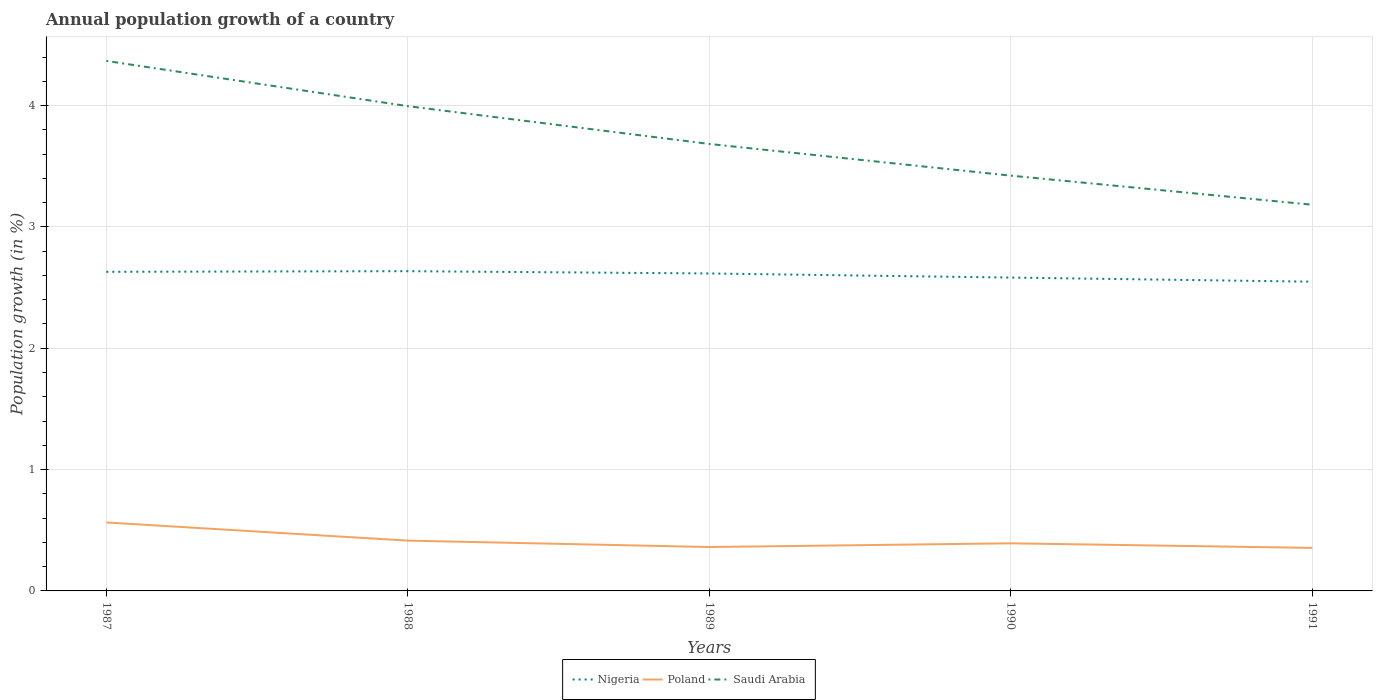How many different coloured lines are there?
Offer a very short reply. 3. Across all years, what is the maximum annual population growth in Saudi Arabia?
Your answer should be very brief. 3.18. In which year was the annual population growth in Saudi Arabia maximum?
Ensure brevity in your answer.  1991. What is the total annual population growth in Nigeria in the graph?
Give a very brief answer. 0.01. What is the difference between the highest and the second highest annual population growth in Saudi Arabia?
Your answer should be very brief. 1.19. How many years are there in the graph?
Your answer should be compact. 5. Are the values on the major ticks of Y-axis written in scientific E-notation?
Ensure brevity in your answer.  No. Does the graph contain grids?
Give a very brief answer. Yes. What is the title of the graph?
Make the answer very short. Annual population growth of a country. What is the label or title of the Y-axis?
Provide a succinct answer. Population growth (in %). What is the Population growth (in %) of Nigeria in 1987?
Keep it short and to the point. 2.63. What is the Population growth (in %) in Poland in 1987?
Your answer should be compact. 0.56. What is the Population growth (in %) of Saudi Arabia in 1987?
Provide a short and direct response. 4.37. What is the Population growth (in %) of Nigeria in 1988?
Your answer should be very brief. 2.64. What is the Population growth (in %) of Poland in 1988?
Provide a short and direct response. 0.41. What is the Population growth (in %) of Saudi Arabia in 1988?
Give a very brief answer. 4. What is the Population growth (in %) in Nigeria in 1989?
Provide a short and direct response. 2.62. What is the Population growth (in %) in Poland in 1989?
Provide a succinct answer. 0.36. What is the Population growth (in %) of Saudi Arabia in 1989?
Your answer should be compact. 3.68. What is the Population growth (in %) in Nigeria in 1990?
Your answer should be compact. 2.58. What is the Population growth (in %) of Poland in 1990?
Offer a very short reply. 0.39. What is the Population growth (in %) of Saudi Arabia in 1990?
Make the answer very short. 3.42. What is the Population growth (in %) of Nigeria in 1991?
Your answer should be very brief. 2.55. What is the Population growth (in %) of Poland in 1991?
Your answer should be very brief. 0.35. What is the Population growth (in %) in Saudi Arabia in 1991?
Offer a very short reply. 3.18. Across all years, what is the maximum Population growth (in %) in Nigeria?
Make the answer very short. 2.64. Across all years, what is the maximum Population growth (in %) of Poland?
Provide a succinct answer. 0.56. Across all years, what is the maximum Population growth (in %) in Saudi Arabia?
Your response must be concise. 4.37. Across all years, what is the minimum Population growth (in %) of Nigeria?
Ensure brevity in your answer.  2.55. Across all years, what is the minimum Population growth (in %) in Poland?
Your response must be concise. 0.35. Across all years, what is the minimum Population growth (in %) in Saudi Arabia?
Provide a succinct answer. 3.18. What is the total Population growth (in %) of Nigeria in the graph?
Provide a short and direct response. 13.01. What is the total Population growth (in %) in Poland in the graph?
Ensure brevity in your answer.  2.09. What is the total Population growth (in %) of Saudi Arabia in the graph?
Offer a very short reply. 18.65. What is the difference between the Population growth (in %) in Nigeria in 1987 and that in 1988?
Your answer should be compact. -0.01. What is the difference between the Population growth (in %) of Poland in 1987 and that in 1988?
Your response must be concise. 0.15. What is the difference between the Population growth (in %) in Saudi Arabia in 1987 and that in 1988?
Provide a succinct answer. 0.37. What is the difference between the Population growth (in %) in Nigeria in 1987 and that in 1989?
Offer a very short reply. 0.01. What is the difference between the Population growth (in %) of Poland in 1987 and that in 1989?
Give a very brief answer. 0.2. What is the difference between the Population growth (in %) of Saudi Arabia in 1987 and that in 1989?
Offer a very short reply. 0.68. What is the difference between the Population growth (in %) of Nigeria in 1987 and that in 1990?
Make the answer very short. 0.05. What is the difference between the Population growth (in %) in Poland in 1987 and that in 1990?
Make the answer very short. 0.17. What is the difference between the Population growth (in %) of Saudi Arabia in 1987 and that in 1990?
Offer a terse response. 0.95. What is the difference between the Population growth (in %) of Nigeria in 1987 and that in 1991?
Your response must be concise. 0.08. What is the difference between the Population growth (in %) in Poland in 1987 and that in 1991?
Offer a very short reply. 0.21. What is the difference between the Population growth (in %) in Saudi Arabia in 1987 and that in 1991?
Ensure brevity in your answer.  1.19. What is the difference between the Population growth (in %) of Nigeria in 1988 and that in 1989?
Give a very brief answer. 0.02. What is the difference between the Population growth (in %) of Poland in 1988 and that in 1989?
Provide a short and direct response. 0.05. What is the difference between the Population growth (in %) of Saudi Arabia in 1988 and that in 1989?
Offer a terse response. 0.31. What is the difference between the Population growth (in %) of Nigeria in 1988 and that in 1990?
Give a very brief answer. 0.05. What is the difference between the Population growth (in %) of Poland in 1988 and that in 1990?
Provide a succinct answer. 0.02. What is the difference between the Population growth (in %) in Saudi Arabia in 1988 and that in 1990?
Ensure brevity in your answer.  0.57. What is the difference between the Population growth (in %) of Nigeria in 1988 and that in 1991?
Make the answer very short. 0.09. What is the difference between the Population growth (in %) in Poland in 1988 and that in 1991?
Ensure brevity in your answer.  0.06. What is the difference between the Population growth (in %) in Saudi Arabia in 1988 and that in 1991?
Your answer should be compact. 0.81. What is the difference between the Population growth (in %) in Nigeria in 1989 and that in 1990?
Offer a very short reply. 0.03. What is the difference between the Population growth (in %) of Poland in 1989 and that in 1990?
Offer a terse response. -0.03. What is the difference between the Population growth (in %) in Saudi Arabia in 1989 and that in 1990?
Your answer should be compact. 0.26. What is the difference between the Population growth (in %) of Nigeria in 1989 and that in 1991?
Your answer should be very brief. 0.07. What is the difference between the Population growth (in %) of Poland in 1989 and that in 1991?
Give a very brief answer. 0.01. What is the difference between the Population growth (in %) of Saudi Arabia in 1989 and that in 1991?
Offer a very short reply. 0.5. What is the difference between the Population growth (in %) in Nigeria in 1990 and that in 1991?
Make the answer very short. 0.03. What is the difference between the Population growth (in %) of Poland in 1990 and that in 1991?
Your response must be concise. 0.04. What is the difference between the Population growth (in %) in Saudi Arabia in 1990 and that in 1991?
Offer a very short reply. 0.24. What is the difference between the Population growth (in %) in Nigeria in 1987 and the Population growth (in %) in Poland in 1988?
Give a very brief answer. 2.22. What is the difference between the Population growth (in %) in Nigeria in 1987 and the Population growth (in %) in Saudi Arabia in 1988?
Provide a succinct answer. -1.37. What is the difference between the Population growth (in %) in Poland in 1987 and the Population growth (in %) in Saudi Arabia in 1988?
Your response must be concise. -3.43. What is the difference between the Population growth (in %) of Nigeria in 1987 and the Population growth (in %) of Poland in 1989?
Provide a short and direct response. 2.27. What is the difference between the Population growth (in %) of Nigeria in 1987 and the Population growth (in %) of Saudi Arabia in 1989?
Ensure brevity in your answer.  -1.05. What is the difference between the Population growth (in %) of Poland in 1987 and the Population growth (in %) of Saudi Arabia in 1989?
Keep it short and to the point. -3.12. What is the difference between the Population growth (in %) of Nigeria in 1987 and the Population growth (in %) of Poland in 1990?
Your response must be concise. 2.24. What is the difference between the Population growth (in %) of Nigeria in 1987 and the Population growth (in %) of Saudi Arabia in 1990?
Give a very brief answer. -0.79. What is the difference between the Population growth (in %) in Poland in 1987 and the Population growth (in %) in Saudi Arabia in 1990?
Your answer should be compact. -2.86. What is the difference between the Population growth (in %) of Nigeria in 1987 and the Population growth (in %) of Poland in 1991?
Your response must be concise. 2.28. What is the difference between the Population growth (in %) in Nigeria in 1987 and the Population growth (in %) in Saudi Arabia in 1991?
Ensure brevity in your answer.  -0.55. What is the difference between the Population growth (in %) in Poland in 1987 and the Population growth (in %) in Saudi Arabia in 1991?
Give a very brief answer. -2.62. What is the difference between the Population growth (in %) in Nigeria in 1988 and the Population growth (in %) in Poland in 1989?
Ensure brevity in your answer.  2.27. What is the difference between the Population growth (in %) of Nigeria in 1988 and the Population growth (in %) of Saudi Arabia in 1989?
Provide a succinct answer. -1.05. What is the difference between the Population growth (in %) of Poland in 1988 and the Population growth (in %) of Saudi Arabia in 1989?
Keep it short and to the point. -3.27. What is the difference between the Population growth (in %) in Nigeria in 1988 and the Population growth (in %) in Poland in 1990?
Your answer should be very brief. 2.24. What is the difference between the Population growth (in %) of Nigeria in 1988 and the Population growth (in %) of Saudi Arabia in 1990?
Your response must be concise. -0.79. What is the difference between the Population growth (in %) of Poland in 1988 and the Population growth (in %) of Saudi Arabia in 1990?
Offer a terse response. -3.01. What is the difference between the Population growth (in %) in Nigeria in 1988 and the Population growth (in %) in Poland in 1991?
Provide a succinct answer. 2.28. What is the difference between the Population growth (in %) of Nigeria in 1988 and the Population growth (in %) of Saudi Arabia in 1991?
Provide a short and direct response. -0.55. What is the difference between the Population growth (in %) in Poland in 1988 and the Population growth (in %) in Saudi Arabia in 1991?
Ensure brevity in your answer.  -2.77. What is the difference between the Population growth (in %) of Nigeria in 1989 and the Population growth (in %) of Poland in 1990?
Provide a succinct answer. 2.22. What is the difference between the Population growth (in %) of Nigeria in 1989 and the Population growth (in %) of Saudi Arabia in 1990?
Offer a very short reply. -0.81. What is the difference between the Population growth (in %) in Poland in 1989 and the Population growth (in %) in Saudi Arabia in 1990?
Your response must be concise. -3.06. What is the difference between the Population growth (in %) of Nigeria in 1989 and the Population growth (in %) of Poland in 1991?
Ensure brevity in your answer.  2.26. What is the difference between the Population growth (in %) of Nigeria in 1989 and the Population growth (in %) of Saudi Arabia in 1991?
Ensure brevity in your answer.  -0.57. What is the difference between the Population growth (in %) in Poland in 1989 and the Population growth (in %) in Saudi Arabia in 1991?
Your answer should be compact. -2.82. What is the difference between the Population growth (in %) of Nigeria in 1990 and the Population growth (in %) of Poland in 1991?
Provide a succinct answer. 2.23. What is the difference between the Population growth (in %) in Nigeria in 1990 and the Population growth (in %) in Saudi Arabia in 1991?
Provide a short and direct response. -0.6. What is the difference between the Population growth (in %) in Poland in 1990 and the Population growth (in %) in Saudi Arabia in 1991?
Provide a succinct answer. -2.79. What is the average Population growth (in %) in Nigeria per year?
Make the answer very short. 2.6. What is the average Population growth (in %) in Poland per year?
Make the answer very short. 0.42. What is the average Population growth (in %) in Saudi Arabia per year?
Keep it short and to the point. 3.73. In the year 1987, what is the difference between the Population growth (in %) in Nigeria and Population growth (in %) in Poland?
Your answer should be compact. 2.07. In the year 1987, what is the difference between the Population growth (in %) of Nigeria and Population growth (in %) of Saudi Arabia?
Ensure brevity in your answer.  -1.74. In the year 1987, what is the difference between the Population growth (in %) in Poland and Population growth (in %) in Saudi Arabia?
Give a very brief answer. -3.8. In the year 1988, what is the difference between the Population growth (in %) of Nigeria and Population growth (in %) of Poland?
Ensure brevity in your answer.  2.22. In the year 1988, what is the difference between the Population growth (in %) of Nigeria and Population growth (in %) of Saudi Arabia?
Your answer should be very brief. -1.36. In the year 1988, what is the difference between the Population growth (in %) in Poland and Population growth (in %) in Saudi Arabia?
Offer a very short reply. -3.58. In the year 1989, what is the difference between the Population growth (in %) of Nigeria and Population growth (in %) of Poland?
Keep it short and to the point. 2.25. In the year 1989, what is the difference between the Population growth (in %) of Nigeria and Population growth (in %) of Saudi Arabia?
Provide a short and direct response. -1.07. In the year 1989, what is the difference between the Population growth (in %) in Poland and Population growth (in %) in Saudi Arabia?
Provide a succinct answer. -3.32. In the year 1990, what is the difference between the Population growth (in %) in Nigeria and Population growth (in %) in Poland?
Provide a succinct answer. 2.19. In the year 1990, what is the difference between the Population growth (in %) in Nigeria and Population growth (in %) in Saudi Arabia?
Your answer should be very brief. -0.84. In the year 1990, what is the difference between the Population growth (in %) in Poland and Population growth (in %) in Saudi Arabia?
Provide a short and direct response. -3.03. In the year 1991, what is the difference between the Population growth (in %) in Nigeria and Population growth (in %) in Poland?
Make the answer very short. 2.19. In the year 1991, what is the difference between the Population growth (in %) in Nigeria and Population growth (in %) in Saudi Arabia?
Offer a very short reply. -0.63. In the year 1991, what is the difference between the Population growth (in %) of Poland and Population growth (in %) of Saudi Arabia?
Offer a very short reply. -2.83. What is the ratio of the Population growth (in %) in Nigeria in 1987 to that in 1988?
Provide a succinct answer. 1. What is the ratio of the Population growth (in %) of Poland in 1987 to that in 1988?
Ensure brevity in your answer.  1.36. What is the ratio of the Population growth (in %) in Saudi Arabia in 1987 to that in 1988?
Your response must be concise. 1.09. What is the ratio of the Population growth (in %) in Poland in 1987 to that in 1989?
Your response must be concise. 1.56. What is the ratio of the Population growth (in %) in Saudi Arabia in 1987 to that in 1989?
Your answer should be very brief. 1.19. What is the ratio of the Population growth (in %) in Nigeria in 1987 to that in 1990?
Offer a very short reply. 1.02. What is the ratio of the Population growth (in %) of Poland in 1987 to that in 1990?
Ensure brevity in your answer.  1.44. What is the ratio of the Population growth (in %) of Saudi Arabia in 1987 to that in 1990?
Your response must be concise. 1.28. What is the ratio of the Population growth (in %) in Nigeria in 1987 to that in 1991?
Provide a succinct answer. 1.03. What is the ratio of the Population growth (in %) in Poland in 1987 to that in 1991?
Your answer should be very brief. 1.59. What is the ratio of the Population growth (in %) in Saudi Arabia in 1987 to that in 1991?
Make the answer very short. 1.37. What is the ratio of the Population growth (in %) of Nigeria in 1988 to that in 1989?
Your answer should be very brief. 1.01. What is the ratio of the Population growth (in %) of Poland in 1988 to that in 1989?
Your answer should be very brief. 1.15. What is the ratio of the Population growth (in %) in Saudi Arabia in 1988 to that in 1989?
Offer a terse response. 1.08. What is the ratio of the Population growth (in %) of Nigeria in 1988 to that in 1990?
Your response must be concise. 1.02. What is the ratio of the Population growth (in %) in Poland in 1988 to that in 1990?
Offer a terse response. 1.06. What is the ratio of the Population growth (in %) in Saudi Arabia in 1988 to that in 1990?
Keep it short and to the point. 1.17. What is the ratio of the Population growth (in %) of Nigeria in 1988 to that in 1991?
Offer a very short reply. 1.03. What is the ratio of the Population growth (in %) of Poland in 1988 to that in 1991?
Provide a short and direct response. 1.17. What is the ratio of the Population growth (in %) of Saudi Arabia in 1988 to that in 1991?
Provide a succinct answer. 1.26. What is the ratio of the Population growth (in %) of Nigeria in 1989 to that in 1990?
Offer a terse response. 1.01. What is the ratio of the Population growth (in %) of Poland in 1989 to that in 1990?
Provide a short and direct response. 0.92. What is the ratio of the Population growth (in %) in Saudi Arabia in 1989 to that in 1990?
Your response must be concise. 1.08. What is the ratio of the Population growth (in %) in Nigeria in 1989 to that in 1991?
Provide a succinct answer. 1.03. What is the ratio of the Population growth (in %) in Poland in 1989 to that in 1991?
Ensure brevity in your answer.  1.02. What is the ratio of the Population growth (in %) in Saudi Arabia in 1989 to that in 1991?
Offer a very short reply. 1.16. What is the ratio of the Population growth (in %) of Nigeria in 1990 to that in 1991?
Ensure brevity in your answer.  1.01. What is the ratio of the Population growth (in %) in Poland in 1990 to that in 1991?
Provide a succinct answer. 1.11. What is the ratio of the Population growth (in %) of Saudi Arabia in 1990 to that in 1991?
Your response must be concise. 1.08. What is the difference between the highest and the second highest Population growth (in %) of Nigeria?
Your answer should be very brief. 0.01. What is the difference between the highest and the second highest Population growth (in %) in Poland?
Provide a succinct answer. 0.15. What is the difference between the highest and the second highest Population growth (in %) in Saudi Arabia?
Your answer should be very brief. 0.37. What is the difference between the highest and the lowest Population growth (in %) in Nigeria?
Offer a very short reply. 0.09. What is the difference between the highest and the lowest Population growth (in %) in Poland?
Offer a terse response. 0.21. What is the difference between the highest and the lowest Population growth (in %) in Saudi Arabia?
Provide a short and direct response. 1.19. 